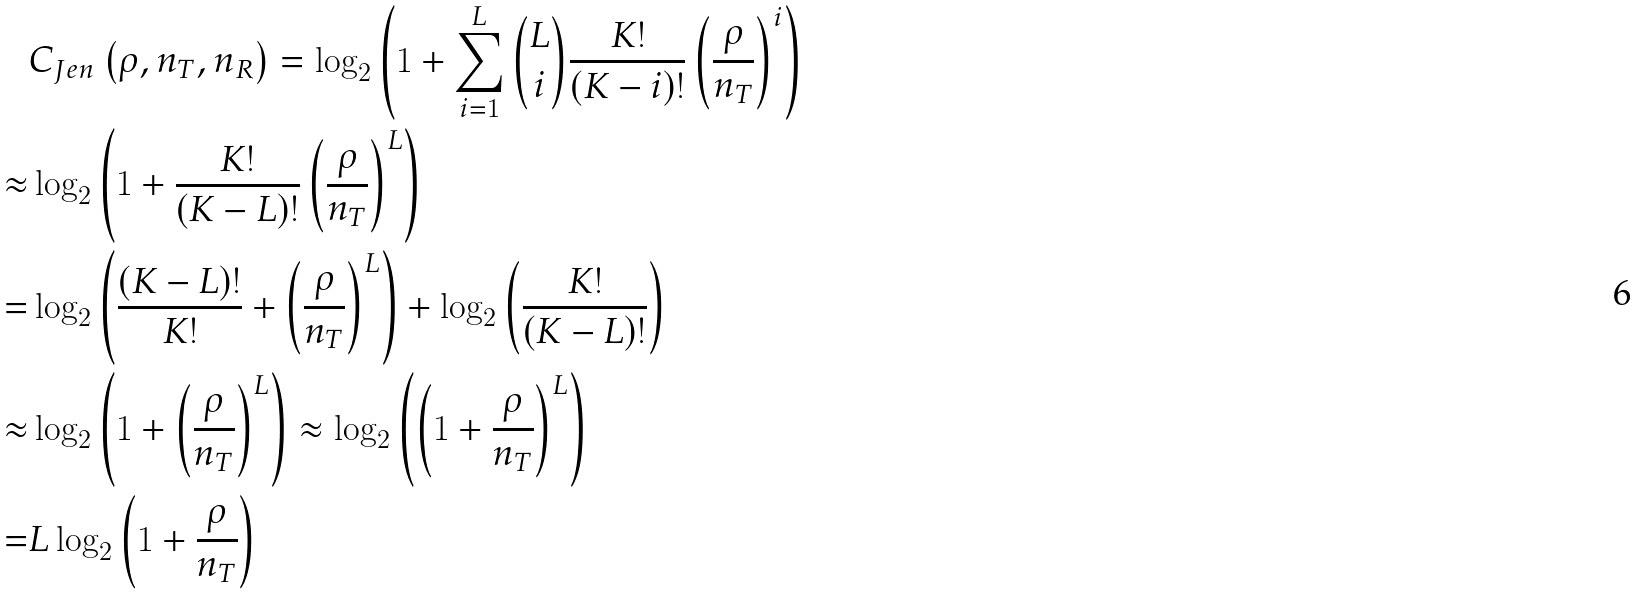Convert formula to latex. <formula><loc_0><loc_0><loc_500><loc_500>& C _ { J e n } \left ( \rho , n _ { T } , n _ { R } \right ) = \log _ { 2 } \left ( 1 + \sum _ { i = 1 } ^ { L } \binom { L } { i } \frac { K ! } { ( K - i ) ! } \left ( \frac { \rho } { n _ { T } } \right ) ^ { i } \right ) \\ \approx & \log _ { 2 } \left ( 1 + \frac { K ! } { ( K - L ) ! } \left ( \frac { \rho } { n _ { T } } \right ) ^ { L } \right ) \\ = & \log _ { 2 } \left ( \frac { ( K - L ) ! } { K ! } + \left ( \frac { \rho } { n _ { T } } \right ) ^ { L } \right ) + \log _ { 2 } \left ( \frac { K ! } { ( K - L ) ! } \right ) \\ \approx & \log _ { 2 } \left ( 1 + \left ( \frac { \rho } { n _ { T } } \right ) ^ { L } \right ) \approx \log _ { 2 } \left ( \left ( 1 + \frac { \rho } { n _ { T } } \right ) ^ { L } \right ) \\ = & L \log _ { 2 } \left ( 1 + \frac { \rho } { n _ { T } } \right )</formula> 